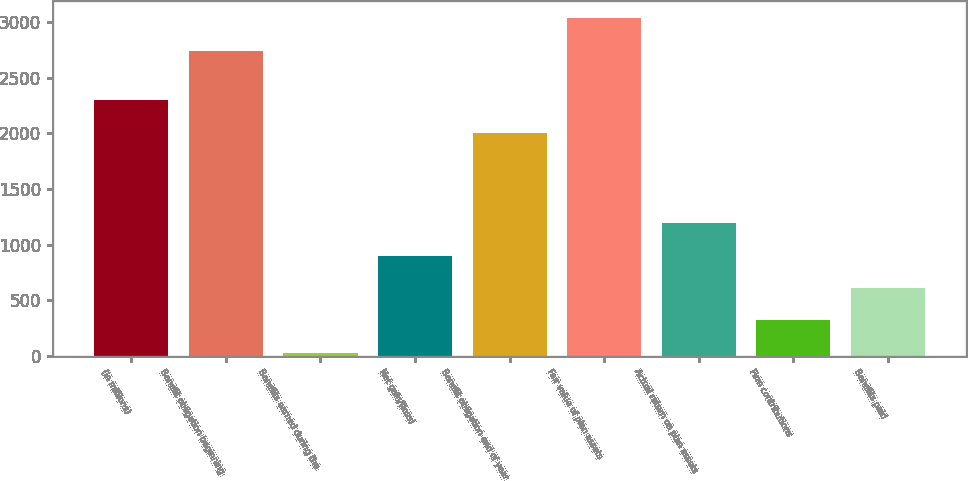Convert chart to OTSL. <chart><loc_0><loc_0><loc_500><loc_500><bar_chart><fcel>(in millions)<fcel>Benefit obligation beginning<fcel>Benefits earned during the<fcel>Net gain/(loss)<fcel>Benefit obligation end of year<fcel>Fair value of plan assets<fcel>Actual return on plan assets<fcel>Firm contributions<fcel>Benefits paid<nl><fcel>2297.4<fcel>2743<fcel>29<fcel>900.2<fcel>2007<fcel>3033.4<fcel>1190.6<fcel>319.4<fcel>609.8<nl></chart> 